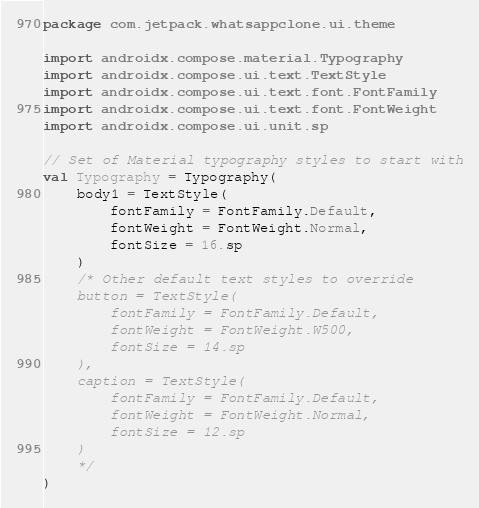Convert code to text. <code><loc_0><loc_0><loc_500><loc_500><_Kotlin_>package com.jetpack.whatsappclone.ui.theme

import androidx.compose.material.Typography
import androidx.compose.ui.text.TextStyle
import androidx.compose.ui.text.font.FontFamily
import androidx.compose.ui.text.font.FontWeight
import androidx.compose.ui.unit.sp

// Set of Material typography styles to start with
val Typography = Typography(
    body1 = TextStyle(
        fontFamily = FontFamily.Default,
        fontWeight = FontWeight.Normal,
        fontSize = 16.sp
    )
    /* Other default text styles to override
    button = TextStyle(
        fontFamily = FontFamily.Default,
        fontWeight = FontWeight.W500,
        fontSize = 14.sp
    ),
    caption = TextStyle(
        fontFamily = FontFamily.Default,
        fontWeight = FontWeight.Normal,
        fontSize = 12.sp
    )
    */
)</code> 